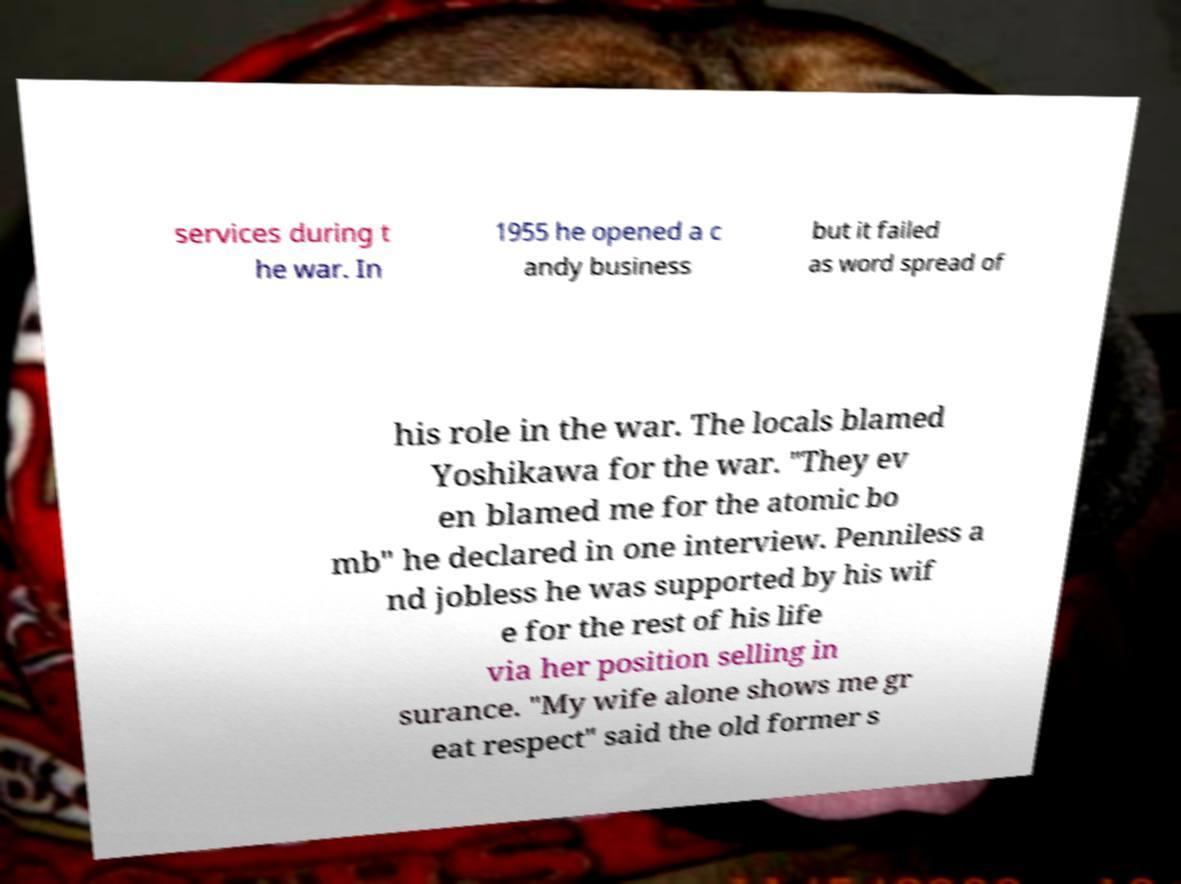Can you read and provide the text displayed in the image?This photo seems to have some interesting text. Can you extract and type it out for me? services during t he war. In 1955 he opened a c andy business but it failed as word spread of his role in the war. The locals blamed Yoshikawa for the war. "They ev en blamed me for the atomic bo mb" he declared in one interview. Penniless a nd jobless he was supported by his wif e for the rest of his life via her position selling in surance. "My wife alone shows me gr eat respect" said the old former s 